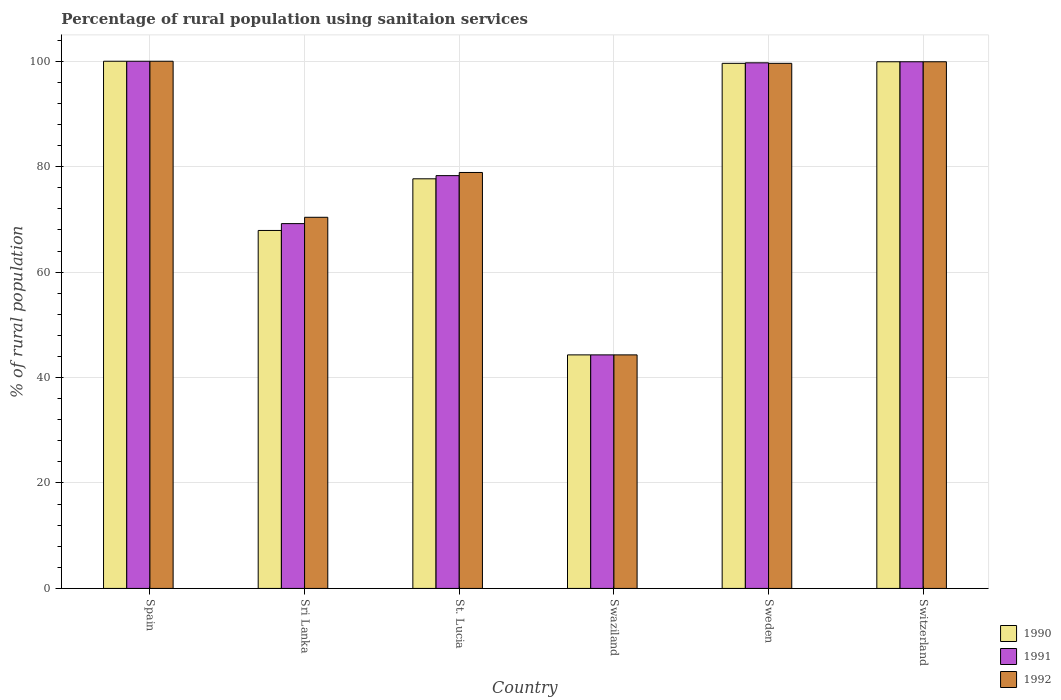How many groups of bars are there?
Keep it short and to the point. 6. Are the number of bars per tick equal to the number of legend labels?
Ensure brevity in your answer.  Yes. Are the number of bars on each tick of the X-axis equal?
Your answer should be compact. Yes. How many bars are there on the 1st tick from the left?
Your response must be concise. 3. What is the label of the 4th group of bars from the left?
Offer a terse response. Swaziland. In how many cases, is the number of bars for a given country not equal to the number of legend labels?
Provide a succinct answer. 0. Across all countries, what is the minimum percentage of rural population using sanitaion services in 1991?
Offer a terse response. 44.3. In which country was the percentage of rural population using sanitaion services in 1990 minimum?
Offer a terse response. Swaziland. What is the total percentage of rural population using sanitaion services in 1990 in the graph?
Offer a terse response. 489.4. What is the difference between the percentage of rural population using sanitaion services in 1990 in Spain and that in Sri Lanka?
Provide a short and direct response. 32.1. What is the difference between the percentage of rural population using sanitaion services in 1991 in St. Lucia and the percentage of rural population using sanitaion services in 1990 in Sri Lanka?
Your response must be concise. 10.4. What is the average percentage of rural population using sanitaion services in 1990 per country?
Make the answer very short. 81.57. What is the ratio of the percentage of rural population using sanitaion services in 1992 in Swaziland to that in Switzerland?
Keep it short and to the point. 0.44. What is the difference between the highest and the second highest percentage of rural population using sanitaion services in 1991?
Your response must be concise. -0.2. What is the difference between the highest and the lowest percentage of rural population using sanitaion services in 1991?
Your response must be concise. 55.7. Is it the case that in every country, the sum of the percentage of rural population using sanitaion services in 1992 and percentage of rural population using sanitaion services in 1991 is greater than the percentage of rural population using sanitaion services in 1990?
Your response must be concise. Yes. What is the difference between two consecutive major ticks on the Y-axis?
Your answer should be very brief. 20. Are the values on the major ticks of Y-axis written in scientific E-notation?
Your answer should be compact. No. How many legend labels are there?
Provide a succinct answer. 3. How are the legend labels stacked?
Provide a short and direct response. Vertical. What is the title of the graph?
Your response must be concise. Percentage of rural population using sanitaion services. What is the label or title of the Y-axis?
Make the answer very short. % of rural population. What is the % of rural population in 1990 in Spain?
Ensure brevity in your answer.  100. What is the % of rural population of 1992 in Spain?
Make the answer very short. 100. What is the % of rural population of 1990 in Sri Lanka?
Offer a terse response. 67.9. What is the % of rural population in 1991 in Sri Lanka?
Your response must be concise. 69.2. What is the % of rural population in 1992 in Sri Lanka?
Provide a succinct answer. 70.4. What is the % of rural population in 1990 in St. Lucia?
Ensure brevity in your answer.  77.7. What is the % of rural population of 1991 in St. Lucia?
Offer a very short reply. 78.3. What is the % of rural population of 1992 in St. Lucia?
Make the answer very short. 78.9. What is the % of rural population of 1990 in Swaziland?
Give a very brief answer. 44.3. What is the % of rural population of 1991 in Swaziland?
Offer a terse response. 44.3. What is the % of rural population of 1992 in Swaziland?
Offer a terse response. 44.3. What is the % of rural population in 1990 in Sweden?
Provide a short and direct response. 99.6. What is the % of rural population in 1991 in Sweden?
Offer a very short reply. 99.7. What is the % of rural population in 1992 in Sweden?
Ensure brevity in your answer.  99.6. What is the % of rural population of 1990 in Switzerland?
Provide a succinct answer. 99.9. What is the % of rural population in 1991 in Switzerland?
Give a very brief answer. 99.9. What is the % of rural population in 1992 in Switzerland?
Offer a terse response. 99.9. Across all countries, what is the maximum % of rural population in 1991?
Ensure brevity in your answer.  100. Across all countries, what is the maximum % of rural population of 1992?
Offer a very short reply. 100. Across all countries, what is the minimum % of rural population in 1990?
Ensure brevity in your answer.  44.3. Across all countries, what is the minimum % of rural population in 1991?
Make the answer very short. 44.3. Across all countries, what is the minimum % of rural population of 1992?
Offer a very short reply. 44.3. What is the total % of rural population in 1990 in the graph?
Offer a very short reply. 489.4. What is the total % of rural population in 1991 in the graph?
Your answer should be very brief. 491.4. What is the total % of rural population of 1992 in the graph?
Provide a succinct answer. 493.1. What is the difference between the % of rural population in 1990 in Spain and that in Sri Lanka?
Your answer should be very brief. 32.1. What is the difference between the % of rural population of 1991 in Spain and that in Sri Lanka?
Give a very brief answer. 30.8. What is the difference between the % of rural population in 1992 in Spain and that in Sri Lanka?
Offer a very short reply. 29.6. What is the difference between the % of rural population in 1990 in Spain and that in St. Lucia?
Ensure brevity in your answer.  22.3. What is the difference between the % of rural population of 1991 in Spain and that in St. Lucia?
Offer a terse response. 21.7. What is the difference between the % of rural population in 1992 in Spain and that in St. Lucia?
Keep it short and to the point. 21.1. What is the difference between the % of rural population in 1990 in Spain and that in Swaziland?
Make the answer very short. 55.7. What is the difference between the % of rural population of 1991 in Spain and that in Swaziland?
Provide a succinct answer. 55.7. What is the difference between the % of rural population in 1992 in Spain and that in Swaziland?
Offer a terse response. 55.7. What is the difference between the % of rural population of 1991 in Spain and that in Sweden?
Provide a short and direct response. 0.3. What is the difference between the % of rural population of 1992 in Spain and that in Sweden?
Keep it short and to the point. 0.4. What is the difference between the % of rural population in 1990 in Spain and that in Switzerland?
Make the answer very short. 0.1. What is the difference between the % of rural population in 1991 in Spain and that in Switzerland?
Your response must be concise. 0.1. What is the difference between the % of rural population of 1991 in Sri Lanka and that in St. Lucia?
Give a very brief answer. -9.1. What is the difference between the % of rural population of 1990 in Sri Lanka and that in Swaziland?
Give a very brief answer. 23.6. What is the difference between the % of rural population of 1991 in Sri Lanka and that in Swaziland?
Offer a terse response. 24.9. What is the difference between the % of rural population in 1992 in Sri Lanka and that in Swaziland?
Make the answer very short. 26.1. What is the difference between the % of rural population of 1990 in Sri Lanka and that in Sweden?
Offer a terse response. -31.7. What is the difference between the % of rural population in 1991 in Sri Lanka and that in Sweden?
Offer a terse response. -30.5. What is the difference between the % of rural population in 1992 in Sri Lanka and that in Sweden?
Provide a short and direct response. -29.2. What is the difference between the % of rural population in 1990 in Sri Lanka and that in Switzerland?
Your answer should be compact. -32. What is the difference between the % of rural population of 1991 in Sri Lanka and that in Switzerland?
Give a very brief answer. -30.7. What is the difference between the % of rural population in 1992 in Sri Lanka and that in Switzerland?
Provide a short and direct response. -29.5. What is the difference between the % of rural population in 1990 in St. Lucia and that in Swaziland?
Keep it short and to the point. 33.4. What is the difference between the % of rural population in 1991 in St. Lucia and that in Swaziland?
Offer a terse response. 34. What is the difference between the % of rural population in 1992 in St. Lucia and that in Swaziland?
Offer a very short reply. 34.6. What is the difference between the % of rural population in 1990 in St. Lucia and that in Sweden?
Your response must be concise. -21.9. What is the difference between the % of rural population in 1991 in St. Lucia and that in Sweden?
Your answer should be compact. -21.4. What is the difference between the % of rural population in 1992 in St. Lucia and that in Sweden?
Keep it short and to the point. -20.7. What is the difference between the % of rural population in 1990 in St. Lucia and that in Switzerland?
Your answer should be very brief. -22.2. What is the difference between the % of rural population in 1991 in St. Lucia and that in Switzerland?
Your response must be concise. -21.6. What is the difference between the % of rural population of 1992 in St. Lucia and that in Switzerland?
Ensure brevity in your answer.  -21. What is the difference between the % of rural population in 1990 in Swaziland and that in Sweden?
Your answer should be compact. -55.3. What is the difference between the % of rural population in 1991 in Swaziland and that in Sweden?
Your answer should be very brief. -55.4. What is the difference between the % of rural population of 1992 in Swaziland and that in Sweden?
Your answer should be very brief. -55.3. What is the difference between the % of rural population in 1990 in Swaziland and that in Switzerland?
Offer a very short reply. -55.6. What is the difference between the % of rural population of 1991 in Swaziland and that in Switzerland?
Keep it short and to the point. -55.6. What is the difference between the % of rural population in 1992 in Swaziland and that in Switzerland?
Provide a succinct answer. -55.6. What is the difference between the % of rural population of 1990 in Sweden and that in Switzerland?
Offer a very short reply. -0.3. What is the difference between the % of rural population of 1990 in Spain and the % of rural population of 1991 in Sri Lanka?
Your response must be concise. 30.8. What is the difference between the % of rural population in 1990 in Spain and the % of rural population in 1992 in Sri Lanka?
Provide a short and direct response. 29.6. What is the difference between the % of rural population in 1991 in Spain and the % of rural population in 1992 in Sri Lanka?
Offer a very short reply. 29.6. What is the difference between the % of rural population in 1990 in Spain and the % of rural population in 1991 in St. Lucia?
Your response must be concise. 21.7. What is the difference between the % of rural population in 1990 in Spain and the % of rural population in 1992 in St. Lucia?
Provide a short and direct response. 21.1. What is the difference between the % of rural population in 1991 in Spain and the % of rural population in 1992 in St. Lucia?
Your answer should be very brief. 21.1. What is the difference between the % of rural population of 1990 in Spain and the % of rural population of 1991 in Swaziland?
Keep it short and to the point. 55.7. What is the difference between the % of rural population of 1990 in Spain and the % of rural population of 1992 in Swaziland?
Your answer should be compact. 55.7. What is the difference between the % of rural population of 1991 in Spain and the % of rural population of 1992 in Swaziland?
Your response must be concise. 55.7. What is the difference between the % of rural population in 1990 in Spain and the % of rural population in 1991 in Sweden?
Keep it short and to the point. 0.3. What is the difference between the % of rural population of 1991 in Spain and the % of rural population of 1992 in Sweden?
Offer a very short reply. 0.4. What is the difference between the % of rural population of 1990 in Spain and the % of rural population of 1991 in Switzerland?
Keep it short and to the point. 0.1. What is the difference between the % of rural population of 1990 in Sri Lanka and the % of rural population of 1991 in St. Lucia?
Offer a terse response. -10.4. What is the difference between the % of rural population of 1990 in Sri Lanka and the % of rural population of 1991 in Swaziland?
Keep it short and to the point. 23.6. What is the difference between the % of rural population of 1990 in Sri Lanka and the % of rural population of 1992 in Swaziland?
Provide a succinct answer. 23.6. What is the difference between the % of rural population of 1991 in Sri Lanka and the % of rural population of 1992 in Swaziland?
Give a very brief answer. 24.9. What is the difference between the % of rural population of 1990 in Sri Lanka and the % of rural population of 1991 in Sweden?
Your response must be concise. -31.8. What is the difference between the % of rural population of 1990 in Sri Lanka and the % of rural population of 1992 in Sweden?
Your answer should be very brief. -31.7. What is the difference between the % of rural population of 1991 in Sri Lanka and the % of rural population of 1992 in Sweden?
Offer a very short reply. -30.4. What is the difference between the % of rural population of 1990 in Sri Lanka and the % of rural population of 1991 in Switzerland?
Your response must be concise. -32. What is the difference between the % of rural population of 1990 in Sri Lanka and the % of rural population of 1992 in Switzerland?
Offer a terse response. -32. What is the difference between the % of rural population in 1991 in Sri Lanka and the % of rural population in 1992 in Switzerland?
Provide a short and direct response. -30.7. What is the difference between the % of rural population in 1990 in St. Lucia and the % of rural population in 1991 in Swaziland?
Give a very brief answer. 33.4. What is the difference between the % of rural population of 1990 in St. Lucia and the % of rural population of 1992 in Swaziland?
Give a very brief answer. 33.4. What is the difference between the % of rural population in 1990 in St. Lucia and the % of rural population in 1992 in Sweden?
Your response must be concise. -21.9. What is the difference between the % of rural population in 1991 in St. Lucia and the % of rural population in 1992 in Sweden?
Ensure brevity in your answer.  -21.3. What is the difference between the % of rural population in 1990 in St. Lucia and the % of rural population in 1991 in Switzerland?
Offer a terse response. -22.2. What is the difference between the % of rural population of 1990 in St. Lucia and the % of rural population of 1992 in Switzerland?
Your answer should be very brief. -22.2. What is the difference between the % of rural population of 1991 in St. Lucia and the % of rural population of 1992 in Switzerland?
Provide a short and direct response. -21.6. What is the difference between the % of rural population in 1990 in Swaziland and the % of rural population in 1991 in Sweden?
Offer a very short reply. -55.4. What is the difference between the % of rural population of 1990 in Swaziland and the % of rural population of 1992 in Sweden?
Your answer should be very brief. -55.3. What is the difference between the % of rural population in 1991 in Swaziland and the % of rural population in 1992 in Sweden?
Make the answer very short. -55.3. What is the difference between the % of rural population in 1990 in Swaziland and the % of rural population in 1991 in Switzerland?
Offer a very short reply. -55.6. What is the difference between the % of rural population of 1990 in Swaziland and the % of rural population of 1992 in Switzerland?
Provide a short and direct response. -55.6. What is the difference between the % of rural population of 1991 in Swaziland and the % of rural population of 1992 in Switzerland?
Make the answer very short. -55.6. What is the difference between the % of rural population of 1990 in Sweden and the % of rural population of 1991 in Switzerland?
Your answer should be very brief. -0.3. What is the difference between the % of rural population in 1991 in Sweden and the % of rural population in 1992 in Switzerland?
Your answer should be very brief. -0.2. What is the average % of rural population of 1990 per country?
Your answer should be compact. 81.57. What is the average % of rural population of 1991 per country?
Your answer should be very brief. 81.9. What is the average % of rural population of 1992 per country?
Make the answer very short. 82.18. What is the difference between the % of rural population in 1990 and % of rural population in 1991 in Spain?
Offer a terse response. 0. What is the difference between the % of rural population of 1990 and % of rural population of 1992 in Spain?
Provide a succinct answer. 0. What is the difference between the % of rural population of 1990 and % of rural population of 1992 in Sri Lanka?
Offer a very short reply. -2.5. What is the difference between the % of rural population of 1991 and % of rural population of 1992 in St. Lucia?
Offer a very short reply. -0.6. What is the difference between the % of rural population in 1990 and % of rural population in 1991 in Swaziland?
Your response must be concise. 0. What is the difference between the % of rural population in 1990 and % of rural population in 1992 in Swaziland?
Offer a terse response. 0. What is the difference between the % of rural population of 1990 and % of rural population of 1991 in Sweden?
Your response must be concise. -0.1. What is the difference between the % of rural population of 1990 and % of rural population of 1991 in Switzerland?
Keep it short and to the point. 0. What is the difference between the % of rural population in 1991 and % of rural population in 1992 in Switzerland?
Keep it short and to the point. 0. What is the ratio of the % of rural population in 1990 in Spain to that in Sri Lanka?
Offer a very short reply. 1.47. What is the ratio of the % of rural population in 1991 in Spain to that in Sri Lanka?
Provide a short and direct response. 1.45. What is the ratio of the % of rural population of 1992 in Spain to that in Sri Lanka?
Keep it short and to the point. 1.42. What is the ratio of the % of rural population in 1990 in Spain to that in St. Lucia?
Keep it short and to the point. 1.29. What is the ratio of the % of rural population in 1991 in Spain to that in St. Lucia?
Your answer should be very brief. 1.28. What is the ratio of the % of rural population in 1992 in Spain to that in St. Lucia?
Provide a short and direct response. 1.27. What is the ratio of the % of rural population in 1990 in Spain to that in Swaziland?
Make the answer very short. 2.26. What is the ratio of the % of rural population of 1991 in Spain to that in Swaziland?
Offer a very short reply. 2.26. What is the ratio of the % of rural population of 1992 in Spain to that in Swaziland?
Your response must be concise. 2.26. What is the ratio of the % of rural population of 1990 in Spain to that in Sweden?
Your answer should be very brief. 1. What is the ratio of the % of rural population in 1991 in Spain to that in Sweden?
Your answer should be very brief. 1. What is the ratio of the % of rural population of 1992 in Spain to that in Switzerland?
Your response must be concise. 1. What is the ratio of the % of rural population in 1990 in Sri Lanka to that in St. Lucia?
Your response must be concise. 0.87. What is the ratio of the % of rural population in 1991 in Sri Lanka to that in St. Lucia?
Offer a terse response. 0.88. What is the ratio of the % of rural population in 1992 in Sri Lanka to that in St. Lucia?
Give a very brief answer. 0.89. What is the ratio of the % of rural population of 1990 in Sri Lanka to that in Swaziland?
Keep it short and to the point. 1.53. What is the ratio of the % of rural population of 1991 in Sri Lanka to that in Swaziland?
Offer a very short reply. 1.56. What is the ratio of the % of rural population of 1992 in Sri Lanka to that in Swaziland?
Your answer should be compact. 1.59. What is the ratio of the % of rural population in 1990 in Sri Lanka to that in Sweden?
Ensure brevity in your answer.  0.68. What is the ratio of the % of rural population of 1991 in Sri Lanka to that in Sweden?
Give a very brief answer. 0.69. What is the ratio of the % of rural population in 1992 in Sri Lanka to that in Sweden?
Offer a very short reply. 0.71. What is the ratio of the % of rural population of 1990 in Sri Lanka to that in Switzerland?
Your response must be concise. 0.68. What is the ratio of the % of rural population in 1991 in Sri Lanka to that in Switzerland?
Ensure brevity in your answer.  0.69. What is the ratio of the % of rural population of 1992 in Sri Lanka to that in Switzerland?
Give a very brief answer. 0.7. What is the ratio of the % of rural population in 1990 in St. Lucia to that in Swaziland?
Your answer should be compact. 1.75. What is the ratio of the % of rural population in 1991 in St. Lucia to that in Swaziland?
Give a very brief answer. 1.77. What is the ratio of the % of rural population in 1992 in St. Lucia to that in Swaziland?
Your answer should be very brief. 1.78. What is the ratio of the % of rural population of 1990 in St. Lucia to that in Sweden?
Make the answer very short. 0.78. What is the ratio of the % of rural population of 1991 in St. Lucia to that in Sweden?
Keep it short and to the point. 0.79. What is the ratio of the % of rural population of 1992 in St. Lucia to that in Sweden?
Your answer should be very brief. 0.79. What is the ratio of the % of rural population of 1990 in St. Lucia to that in Switzerland?
Offer a terse response. 0.78. What is the ratio of the % of rural population in 1991 in St. Lucia to that in Switzerland?
Offer a very short reply. 0.78. What is the ratio of the % of rural population of 1992 in St. Lucia to that in Switzerland?
Keep it short and to the point. 0.79. What is the ratio of the % of rural population in 1990 in Swaziland to that in Sweden?
Your answer should be very brief. 0.44. What is the ratio of the % of rural population of 1991 in Swaziland to that in Sweden?
Make the answer very short. 0.44. What is the ratio of the % of rural population of 1992 in Swaziland to that in Sweden?
Offer a very short reply. 0.44. What is the ratio of the % of rural population of 1990 in Swaziland to that in Switzerland?
Provide a succinct answer. 0.44. What is the ratio of the % of rural population of 1991 in Swaziland to that in Switzerland?
Offer a very short reply. 0.44. What is the ratio of the % of rural population in 1992 in Swaziland to that in Switzerland?
Ensure brevity in your answer.  0.44. What is the ratio of the % of rural population of 1992 in Sweden to that in Switzerland?
Provide a short and direct response. 1. What is the difference between the highest and the second highest % of rural population in 1990?
Make the answer very short. 0.1. What is the difference between the highest and the second highest % of rural population in 1992?
Keep it short and to the point. 0.1. What is the difference between the highest and the lowest % of rural population of 1990?
Offer a terse response. 55.7. What is the difference between the highest and the lowest % of rural population in 1991?
Your response must be concise. 55.7. What is the difference between the highest and the lowest % of rural population in 1992?
Offer a very short reply. 55.7. 